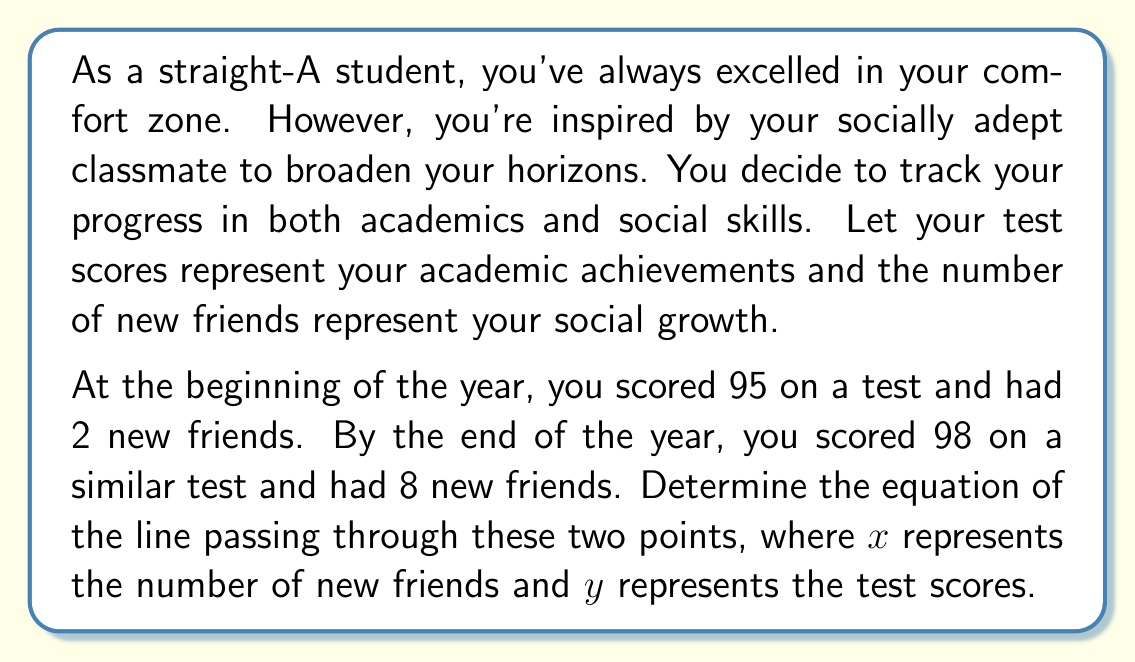Show me your answer to this math problem. To find the equation of a line passing through two points, we can use the point-slope form of a line: $y - y_1 = m(x - x_1)$, where $m$ is the slope of the line.

Let's solve this step-by-step:

1. Identify the two points:
   Point 1: $(x_1, y_1) = (2, 95)$
   Point 2: $(x_2, y_2) = (8, 98)$

2. Calculate the slope $(m)$ using the slope formula:
   $$m = \frac{y_2 - y_1}{x_2 - x_1} = \frac{98 - 95}{8 - 2} = \frac{3}{6} = \frac{1}{2}$$

3. Now that we have the slope, let's use the point-slope form with the first point $(2, 95)$:
   $$y - 95 = \frac{1}{2}(x - 2)$$

4. Expand the right side of the equation:
   $$y - 95 = \frac{1}{2}x - 1$$

5. Add 95 to both sides to isolate $y$:
   $$y = \frac{1}{2}x - 1 + 95$$

6. Simplify:
   $$y = \frac{1}{2}x + 94$$

This is the equation of the line in slope-intercept form $(y = mx + b)$, where $m = \frac{1}{2}$ is the slope and $b = 94$ is the y-intercept.
Answer: $y = \frac{1}{2}x + 94$ 